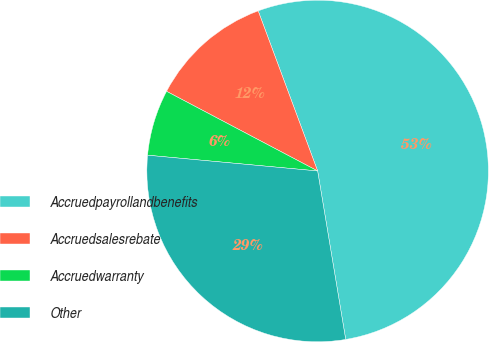<chart> <loc_0><loc_0><loc_500><loc_500><pie_chart><fcel>Accruedpayrollandbenefits<fcel>Accruedsalesrebate<fcel>Accruedwarranty<fcel>Other<nl><fcel>53.03%<fcel>11.62%<fcel>6.25%<fcel>29.1%<nl></chart> 